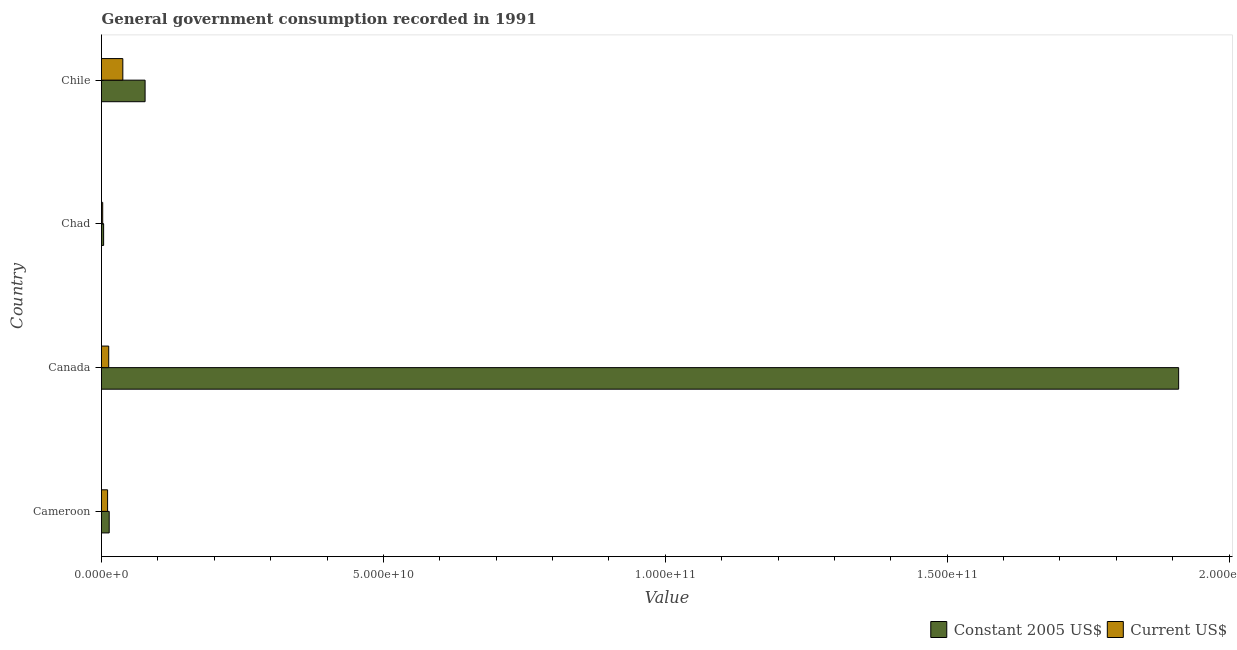How many different coloured bars are there?
Your answer should be compact. 2. How many bars are there on the 1st tick from the bottom?
Your answer should be compact. 2. In how many cases, is the number of bars for a given country not equal to the number of legend labels?
Ensure brevity in your answer.  0. What is the value consumed in current us$ in Cameroon?
Give a very brief answer. 1.08e+09. Across all countries, what is the maximum value consumed in constant 2005 us$?
Provide a short and direct response. 1.91e+11. Across all countries, what is the minimum value consumed in current us$?
Give a very brief answer. 2.12e+08. In which country was the value consumed in current us$ minimum?
Your answer should be compact. Chad. What is the total value consumed in constant 2005 us$ in the graph?
Give a very brief answer. 2.01e+11. What is the difference between the value consumed in constant 2005 us$ in Canada and that in Chad?
Make the answer very short. 1.91e+11. What is the difference between the value consumed in current us$ in Cameroon and the value consumed in constant 2005 us$ in Chad?
Provide a succinct answer. 7.03e+08. What is the average value consumed in current us$ per country?
Your answer should be very brief. 1.59e+09. What is the difference between the value consumed in current us$ and value consumed in constant 2005 us$ in Chad?
Ensure brevity in your answer.  -1.65e+08. In how many countries, is the value consumed in constant 2005 us$ greater than 140000000000 ?
Your response must be concise. 1. What is the ratio of the value consumed in current us$ in Cameroon to that in Canada?
Give a very brief answer. 0.84. Is the difference between the value consumed in current us$ in Cameroon and Canada greater than the difference between the value consumed in constant 2005 us$ in Cameroon and Canada?
Provide a succinct answer. Yes. What is the difference between the highest and the second highest value consumed in current us$?
Provide a succinct answer. 2.50e+09. What is the difference between the highest and the lowest value consumed in current us$?
Ensure brevity in your answer.  3.57e+09. What does the 2nd bar from the top in Cameroon represents?
Give a very brief answer. Constant 2005 US$. What does the 1st bar from the bottom in Canada represents?
Offer a terse response. Constant 2005 US$. How many bars are there?
Your answer should be very brief. 8. Are all the bars in the graph horizontal?
Provide a short and direct response. Yes. What is the difference between two consecutive major ticks on the X-axis?
Offer a very short reply. 5.00e+1. Does the graph contain grids?
Offer a very short reply. No. Where does the legend appear in the graph?
Make the answer very short. Bottom right. How many legend labels are there?
Your answer should be compact. 2. What is the title of the graph?
Give a very brief answer. General government consumption recorded in 1991. Does "Net savings(excluding particulate emission damage)" appear as one of the legend labels in the graph?
Provide a succinct answer. No. What is the label or title of the X-axis?
Your response must be concise. Value. What is the Value of Constant 2005 US$ in Cameroon?
Your response must be concise. 1.36e+09. What is the Value in Current US$ in Cameroon?
Ensure brevity in your answer.  1.08e+09. What is the Value in Constant 2005 US$ in Canada?
Your answer should be compact. 1.91e+11. What is the Value of Current US$ in Canada?
Your answer should be very brief. 1.28e+09. What is the Value in Constant 2005 US$ in Chad?
Your response must be concise. 3.77e+08. What is the Value in Current US$ in Chad?
Ensure brevity in your answer.  2.12e+08. What is the Value in Constant 2005 US$ in Chile?
Ensure brevity in your answer.  7.73e+09. What is the Value of Current US$ in Chile?
Offer a terse response. 3.78e+09. Across all countries, what is the maximum Value in Constant 2005 US$?
Offer a very short reply. 1.91e+11. Across all countries, what is the maximum Value of Current US$?
Your answer should be compact. 3.78e+09. Across all countries, what is the minimum Value of Constant 2005 US$?
Offer a very short reply. 3.77e+08. Across all countries, what is the minimum Value in Current US$?
Make the answer very short. 2.12e+08. What is the total Value in Constant 2005 US$ in the graph?
Your answer should be very brief. 2.01e+11. What is the total Value of Current US$ in the graph?
Offer a terse response. 6.36e+09. What is the difference between the Value of Constant 2005 US$ in Cameroon and that in Canada?
Make the answer very short. -1.90e+11. What is the difference between the Value of Current US$ in Cameroon and that in Canada?
Provide a succinct answer. -2.01e+08. What is the difference between the Value of Constant 2005 US$ in Cameroon and that in Chad?
Give a very brief answer. 9.88e+08. What is the difference between the Value in Current US$ in Cameroon and that in Chad?
Your answer should be very brief. 8.67e+08. What is the difference between the Value of Constant 2005 US$ in Cameroon and that in Chile?
Your answer should be very brief. -6.37e+09. What is the difference between the Value in Current US$ in Cameroon and that in Chile?
Your answer should be very brief. -2.70e+09. What is the difference between the Value in Constant 2005 US$ in Canada and that in Chad?
Ensure brevity in your answer.  1.91e+11. What is the difference between the Value in Current US$ in Canada and that in Chad?
Make the answer very short. 1.07e+09. What is the difference between the Value in Constant 2005 US$ in Canada and that in Chile?
Provide a succinct answer. 1.83e+11. What is the difference between the Value in Current US$ in Canada and that in Chile?
Offer a very short reply. -2.50e+09. What is the difference between the Value in Constant 2005 US$ in Chad and that in Chile?
Your answer should be very brief. -7.35e+09. What is the difference between the Value in Current US$ in Chad and that in Chile?
Your response must be concise. -3.57e+09. What is the difference between the Value of Constant 2005 US$ in Cameroon and the Value of Current US$ in Canada?
Provide a succinct answer. 8.43e+07. What is the difference between the Value in Constant 2005 US$ in Cameroon and the Value in Current US$ in Chad?
Offer a very short reply. 1.15e+09. What is the difference between the Value of Constant 2005 US$ in Cameroon and the Value of Current US$ in Chile?
Your answer should be compact. -2.42e+09. What is the difference between the Value in Constant 2005 US$ in Canada and the Value in Current US$ in Chad?
Offer a terse response. 1.91e+11. What is the difference between the Value of Constant 2005 US$ in Canada and the Value of Current US$ in Chile?
Give a very brief answer. 1.87e+11. What is the difference between the Value of Constant 2005 US$ in Chad and the Value of Current US$ in Chile?
Keep it short and to the point. -3.41e+09. What is the average Value of Constant 2005 US$ per country?
Provide a succinct answer. 5.01e+1. What is the average Value in Current US$ per country?
Offer a very short reply. 1.59e+09. What is the difference between the Value in Constant 2005 US$ and Value in Current US$ in Cameroon?
Provide a succinct answer. 2.85e+08. What is the difference between the Value in Constant 2005 US$ and Value in Current US$ in Canada?
Give a very brief answer. 1.90e+11. What is the difference between the Value in Constant 2005 US$ and Value in Current US$ in Chad?
Keep it short and to the point. 1.65e+08. What is the difference between the Value of Constant 2005 US$ and Value of Current US$ in Chile?
Your answer should be very brief. 3.95e+09. What is the ratio of the Value of Constant 2005 US$ in Cameroon to that in Canada?
Your response must be concise. 0.01. What is the ratio of the Value of Current US$ in Cameroon to that in Canada?
Your answer should be compact. 0.84. What is the ratio of the Value in Constant 2005 US$ in Cameroon to that in Chad?
Make the answer very short. 3.62. What is the ratio of the Value in Current US$ in Cameroon to that in Chad?
Make the answer very short. 5.09. What is the ratio of the Value in Constant 2005 US$ in Cameroon to that in Chile?
Offer a terse response. 0.18. What is the ratio of the Value in Current US$ in Cameroon to that in Chile?
Provide a succinct answer. 0.29. What is the ratio of the Value in Constant 2005 US$ in Canada to that in Chad?
Give a very brief answer. 506.83. What is the ratio of the Value in Current US$ in Canada to that in Chad?
Offer a very short reply. 6.03. What is the ratio of the Value in Constant 2005 US$ in Canada to that in Chile?
Keep it short and to the point. 24.71. What is the ratio of the Value of Current US$ in Canada to that in Chile?
Make the answer very short. 0.34. What is the ratio of the Value in Constant 2005 US$ in Chad to that in Chile?
Provide a short and direct response. 0.05. What is the ratio of the Value of Current US$ in Chad to that in Chile?
Your answer should be very brief. 0.06. What is the difference between the highest and the second highest Value of Constant 2005 US$?
Offer a terse response. 1.83e+11. What is the difference between the highest and the second highest Value of Current US$?
Your response must be concise. 2.50e+09. What is the difference between the highest and the lowest Value of Constant 2005 US$?
Offer a very short reply. 1.91e+11. What is the difference between the highest and the lowest Value in Current US$?
Your response must be concise. 3.57e+09. 